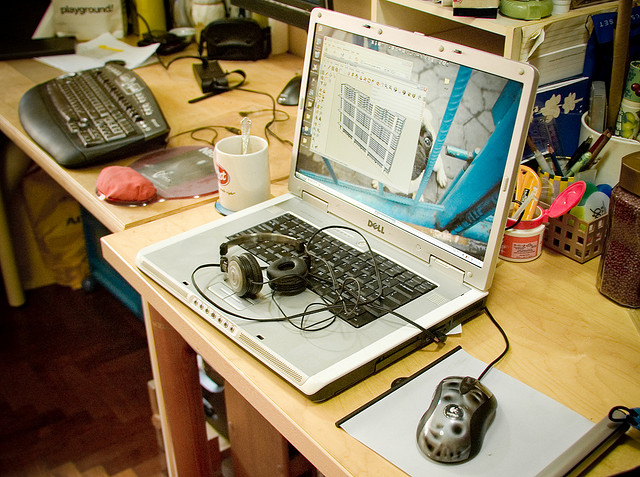Identify the text contained in this image. playground DELL 